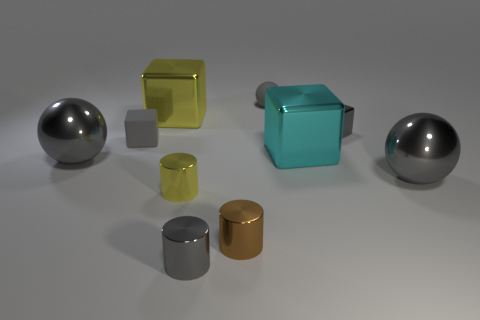Are any tiny purple blocks visible?
Your response must be concise. No. What is the size of the gray sphere that is both in front of the large yellow object and on the right side of the small brown object?
Provide a short and direct response. Large. What is the shape of the large yellow shiny thing?
Make the answer very short. Cube. There is a gray metal ball that is to the right of the cyan metal thing; are there any large gray shiny objects right of it?
Provide a succinct answer. No. There is a yellow object that is the same size as the cyan thing; what is its material?
Provide a succinct answer. Metal. Is there a purple metal thing that has the same size as the yellow shiny cube?
Ensure brevity in your answer.  No. There is a large gray sphere that is on the left side of the tiny brown object; what material is it?
Ensure brevity in your answer.  Metal. Do the tiny block that is on the right side of the large cyan metallic object and the yellow cylinder have the same material?
Give a very brief answer. Yes. There is a gray rubber object that is the same size as the gray matte sphere; what is its shape?
Your answer should be compact. Cube. How many rubber things are the same color as the small matte block?
Provide a succinct answer. 1. 